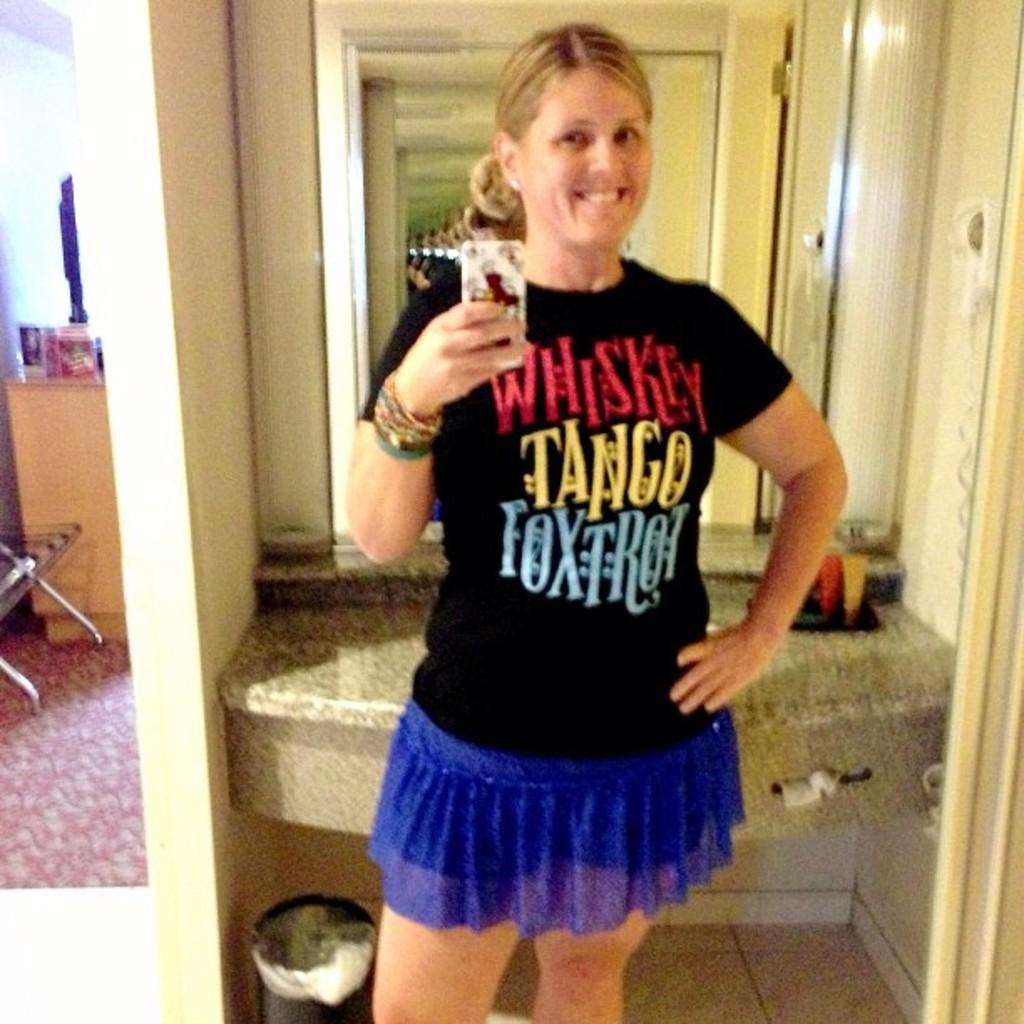<image>
Provide a brief description of the given image. Lady holding cell phone with a black shirt that reads Whiskey Tango Foxtrot. 